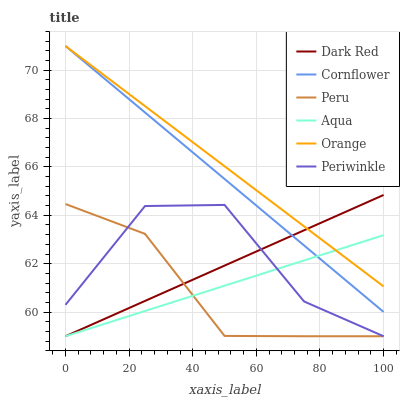Does Peru have the minimum area under the curve?
Answer yes or no. Yes. Does Orange have the maximum area under the curve?
Answer yes or no. Yes. Does Dark Red have the minimum area under the curve?
Answer yes or no. No. Does Dark Red have the maximum area under the curve?
Answer yes or no. No. Is Cornflower the smoothest?
Answer yes or no. Yes. Is Periwinkle the roughest?
Answer yes or no. Yes. Is Aqua the smoothest?
Answer yes or no. No. Is Aqua the roughest?
Answer yes or no. No. Does Dark Red have the lowest value?
Answer yes or no. Yes. Does Orange have the lowest value?
Answer yes or no. No. Does Orange have the highest value?
Answer yes or no. Yes. Does Dark Red have the highest value?
Answer yes or no. No. Is Peru less than Orange?
Answer yes or no. Yes. Is Cornflower greater than Peru?
Answer yes or no. Yes. Does Peru intersect Aqua?
Answer yes or no. Yes. Is Peru less than Aqua?
Answer yes or no. No. Is Peru greater than Aqua?
Answer yes or no. No. Does Peru intersect Orange?
Answer yes or no. No. 